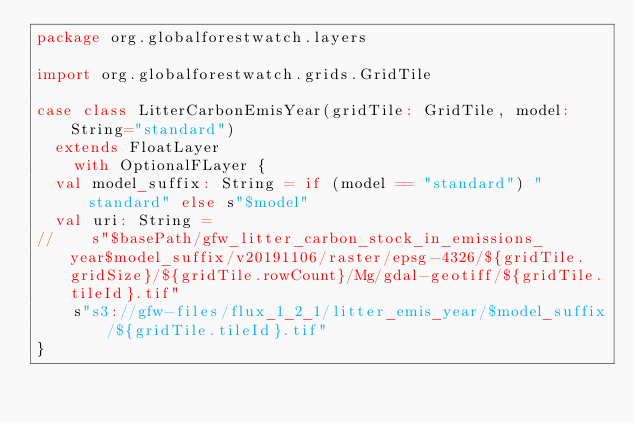<code> <loc_0><loc_0><loc_500><loc_500><_Scala_>package org.globalforestwatch.layers

import org.globalforestwatch.grids.GridTile

case class LitterCarbonEmisYear(gridTile: GridTile, model: String="standard")
  extends FloatLayer
    with OptionalFLayer {
  val model_suffix: String = if (model == "standard") "standard" else s"$model"
  val uri: String =
//    s"$basePath/gfw_litter_carbon_stock_in_emissions_year$model_suffix/v20191106/raster/epsg-4326/${gridTile.gridSize}/${gridTile.rowCount}/Mg/gdal-geotiff/${gridTile.tileId}.tif"
    s"s3://gfw-files/flux_1_2_1/litter_emis_year/$model_suffix/${gridTile.tileId}.tif"
}
</code> 